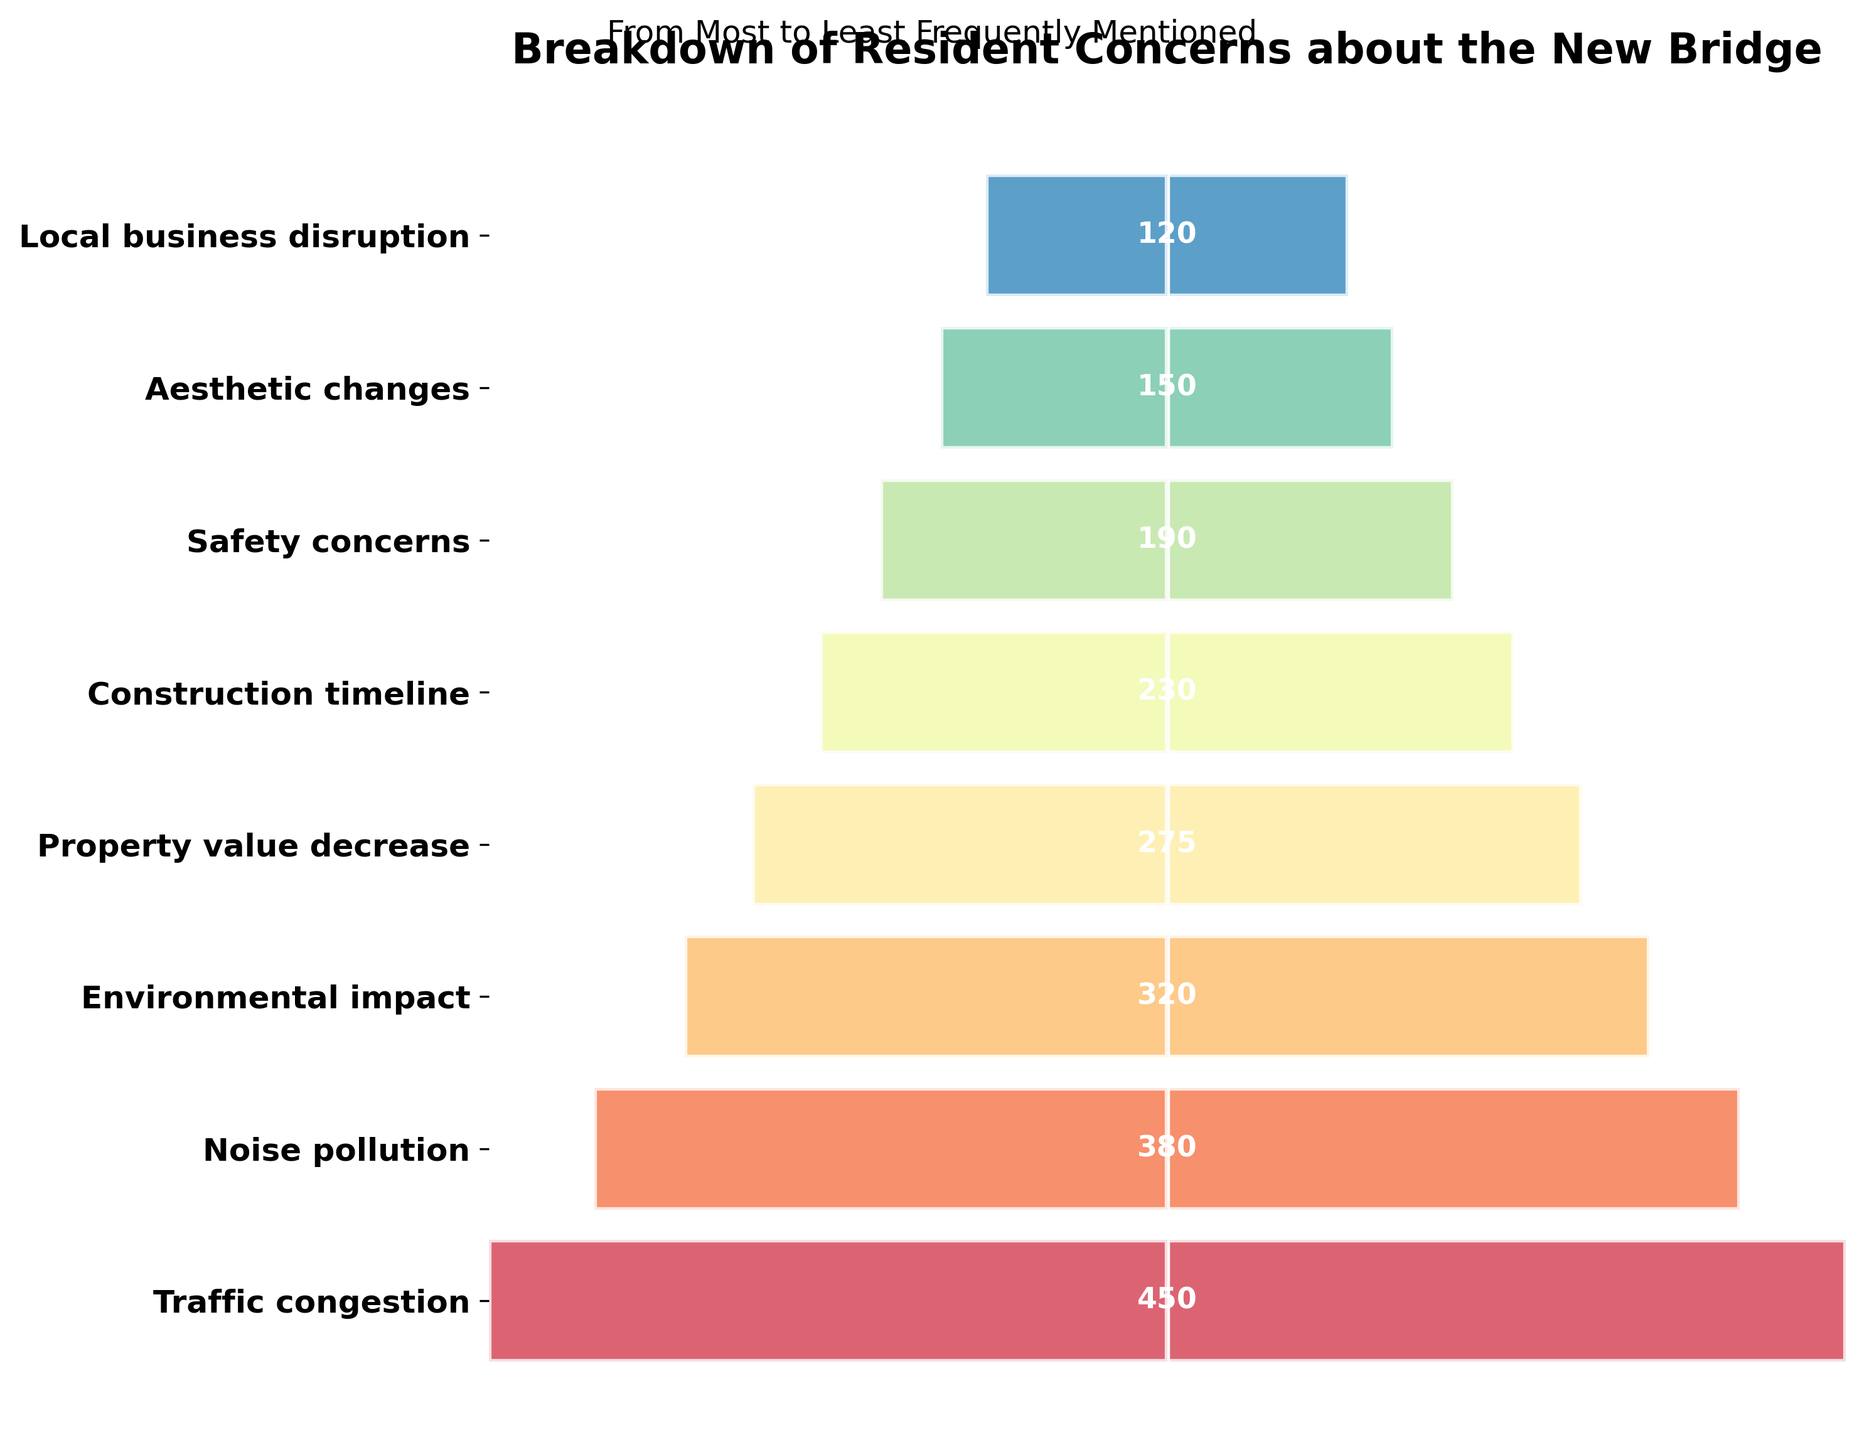What's the main title of the chart? The main title of the chart is located at the top and provides a brief description of what the chart is about.
Answer: Breakdown of Resident Concerns about the New Bridge How many different concerns are listed in the chart? The chart lists all the concerns on the y-axis as labels for the bars.
Answer: 8 Which concern had the highest frequency? By looking at the widest bar in the funnel chart, we can identify the concern with the highest frequency.
Answer: Traffic congestion Which concern had the lowest frequency? By looking at the narrowest bar in the funnel chart, we can identify the concern with the lowest frequency.
Answer: Local business disruption What is the total frequency of the top three concerns? Summing the frequencies of the top three concerns: Traffic congestion (450), Noise pollution (380), and Environmental impact (320).
Answer: 1150 Which concerns have a frequency greater than 300 but less than 400? By examining the bars and their corresponding frequency labels, we identify the concerns that fall within this range.
Answer: Noise pollution and Environmental impact What is the difference in frequency between the top concern and the bottom concern? Subtract the frequency of Local business disruption (120) from the frequency of Traffic congestion (450).
Answer: 330 How does the frequency of Safety concerns compare to Aesthetic changes? Compare the lengths of the bars for Safety concerns (190) and Aesthetic changes (150).
Answer: Safety concerns have a higher frequency than Aesthetic changes What combined frequency do the concerns related to appearance (Property value decrease and Aesthetic changes) and local economy (Local business disruption) have? Add the frequencies of Property value decrease (275), Aesthetic changes (150), and Local business disruption (120).
Answer: 545 What insight can be derived about residents’ priorities based on the relative widths of the bars? The wider bars at the top indicate more frequently mentioned concerns, showing that issues like Traffic congestion and Noise pollution are prioritized higher by residents compared to concerns like Local business disruption and Aesthetic changes, which have narrower bars at the bottom.
Answer: Traffic congestion and Noise pollution are higher priorities 